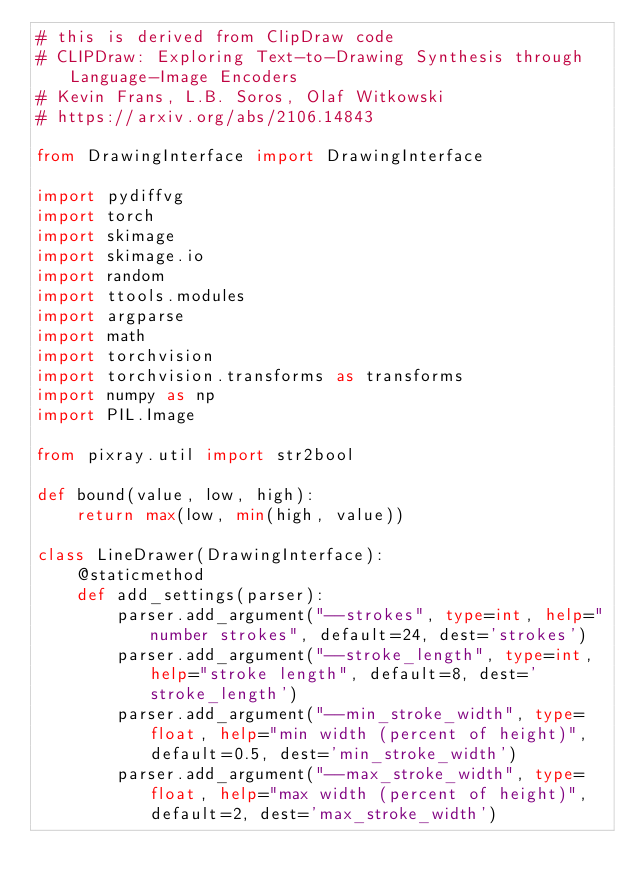<code> <loc_0><loc_0><loc_500><loc_500><_Python_># this is derived from ClipDraw code
# CLIPDraw: Exploring Text-to-Drawing Synthesis through Language-Image Encoders
# Kevin Frans, L.B. Soros, Olaf Witkowski
# https://arxiv.org/abs/2106.14843

from DrawingInterface import DrawingInterface

import pydiffvg
import torch
import skimage
import skimage.io
import random
import ttools.modules
import argparse
import math
import torchvision
import torchvision.transforms as transforms
import numpy as np
import PIL.Image

from pixray.util import str2bool

def bound(value, low, high):
    return max(low, min(high, value))

class LineDrawer(DrawingInterface):
    @staticmethod
    def add_settings(parser):
        parser.add_argument("--strokes", type=int, help="number strokes", default=24, dest='strokes')
        parser.add_argument("--stroke_length", type=int, help="stroke length", default=8, dest='stroke_length')
        parser.add_argument("--min_stroke_width", type=float, help="min width (percent of height)", default=0.5, dest='min_stroke_width')
        parser.add_argument("--max_stroke_width", type=float, help="max width (percent of height)", default=2, dest='max_stroke_width')</code> 